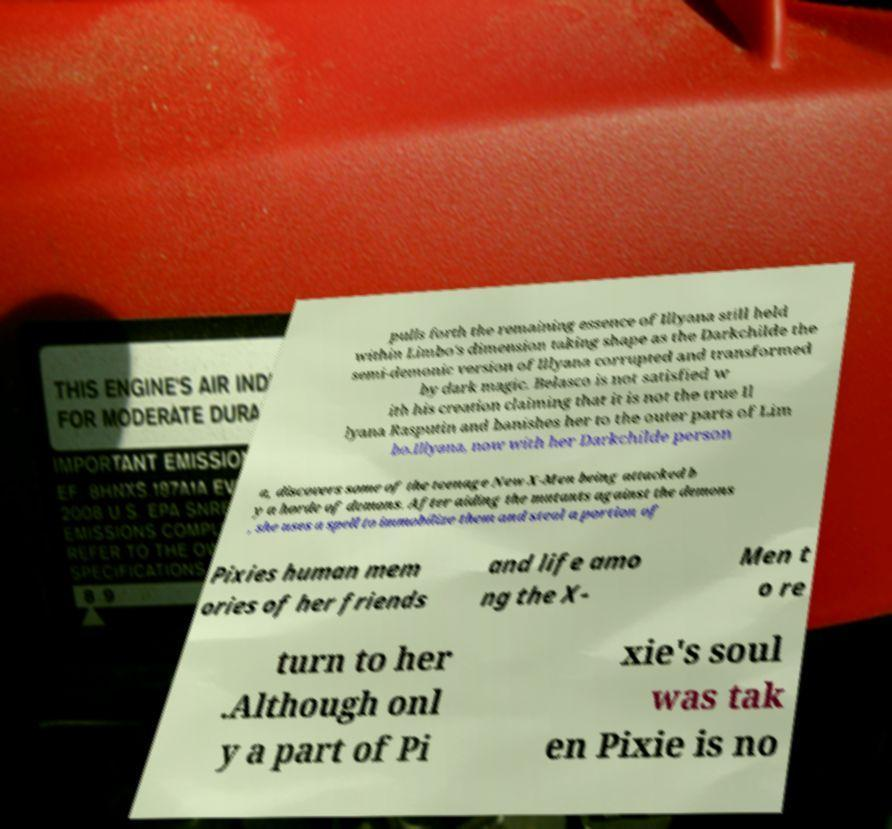What messages or text are displayed in this image? I need them in a readable, typed format. pulls forth the remaining essence of Illyana still held within Limbo's dimension taking shape as the Darkchilde the semi-demonic version of Illyana corrupted and transformed by dark magic. Belasco is not satisfied w ith his creation claiming that it is not the true Il lyana Rasputin and banishes her to the outer parts of Lim bo.Illyana, now with her Darkchilde person a, discovers some of the teenage New X-Men being attacked b y a horde of demons. After aiding the mutants against the demons , she uses a spell to immobilize them and steal a portion of Pixies human mem ories of her friends and life amo ng the X- Men t o re turn to her .Although onl y a part of Pi xie's soul was tak en Pixie is no 